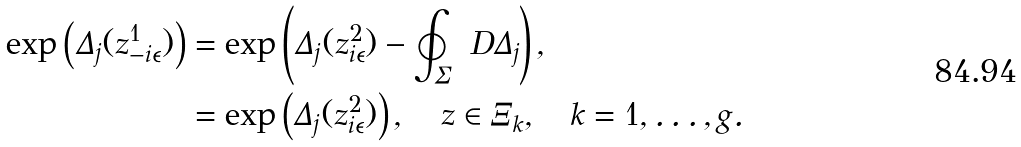Convert formula to latex. <formula><loc_0><loc_0><loc_500><loc_500>\exp \left ( \Delta _ { j } ( z _ { - i \epsilon } ^ { 1 } ) \right ) & = \exp \left ( \Delta _ { j } ( z _ { i \epsilon } ^ { 2 } ) - \oint _ { \Sigma } \ D \Delta _ { j } \right ) , \\ & = \exp \left ( \Delta _ { j } ( z _ { i \epsilon } ^ { 2 } ) \right ) , \quad z \in \Xi _ { k } , \quad k = 1 , \dots , g .</formula> 